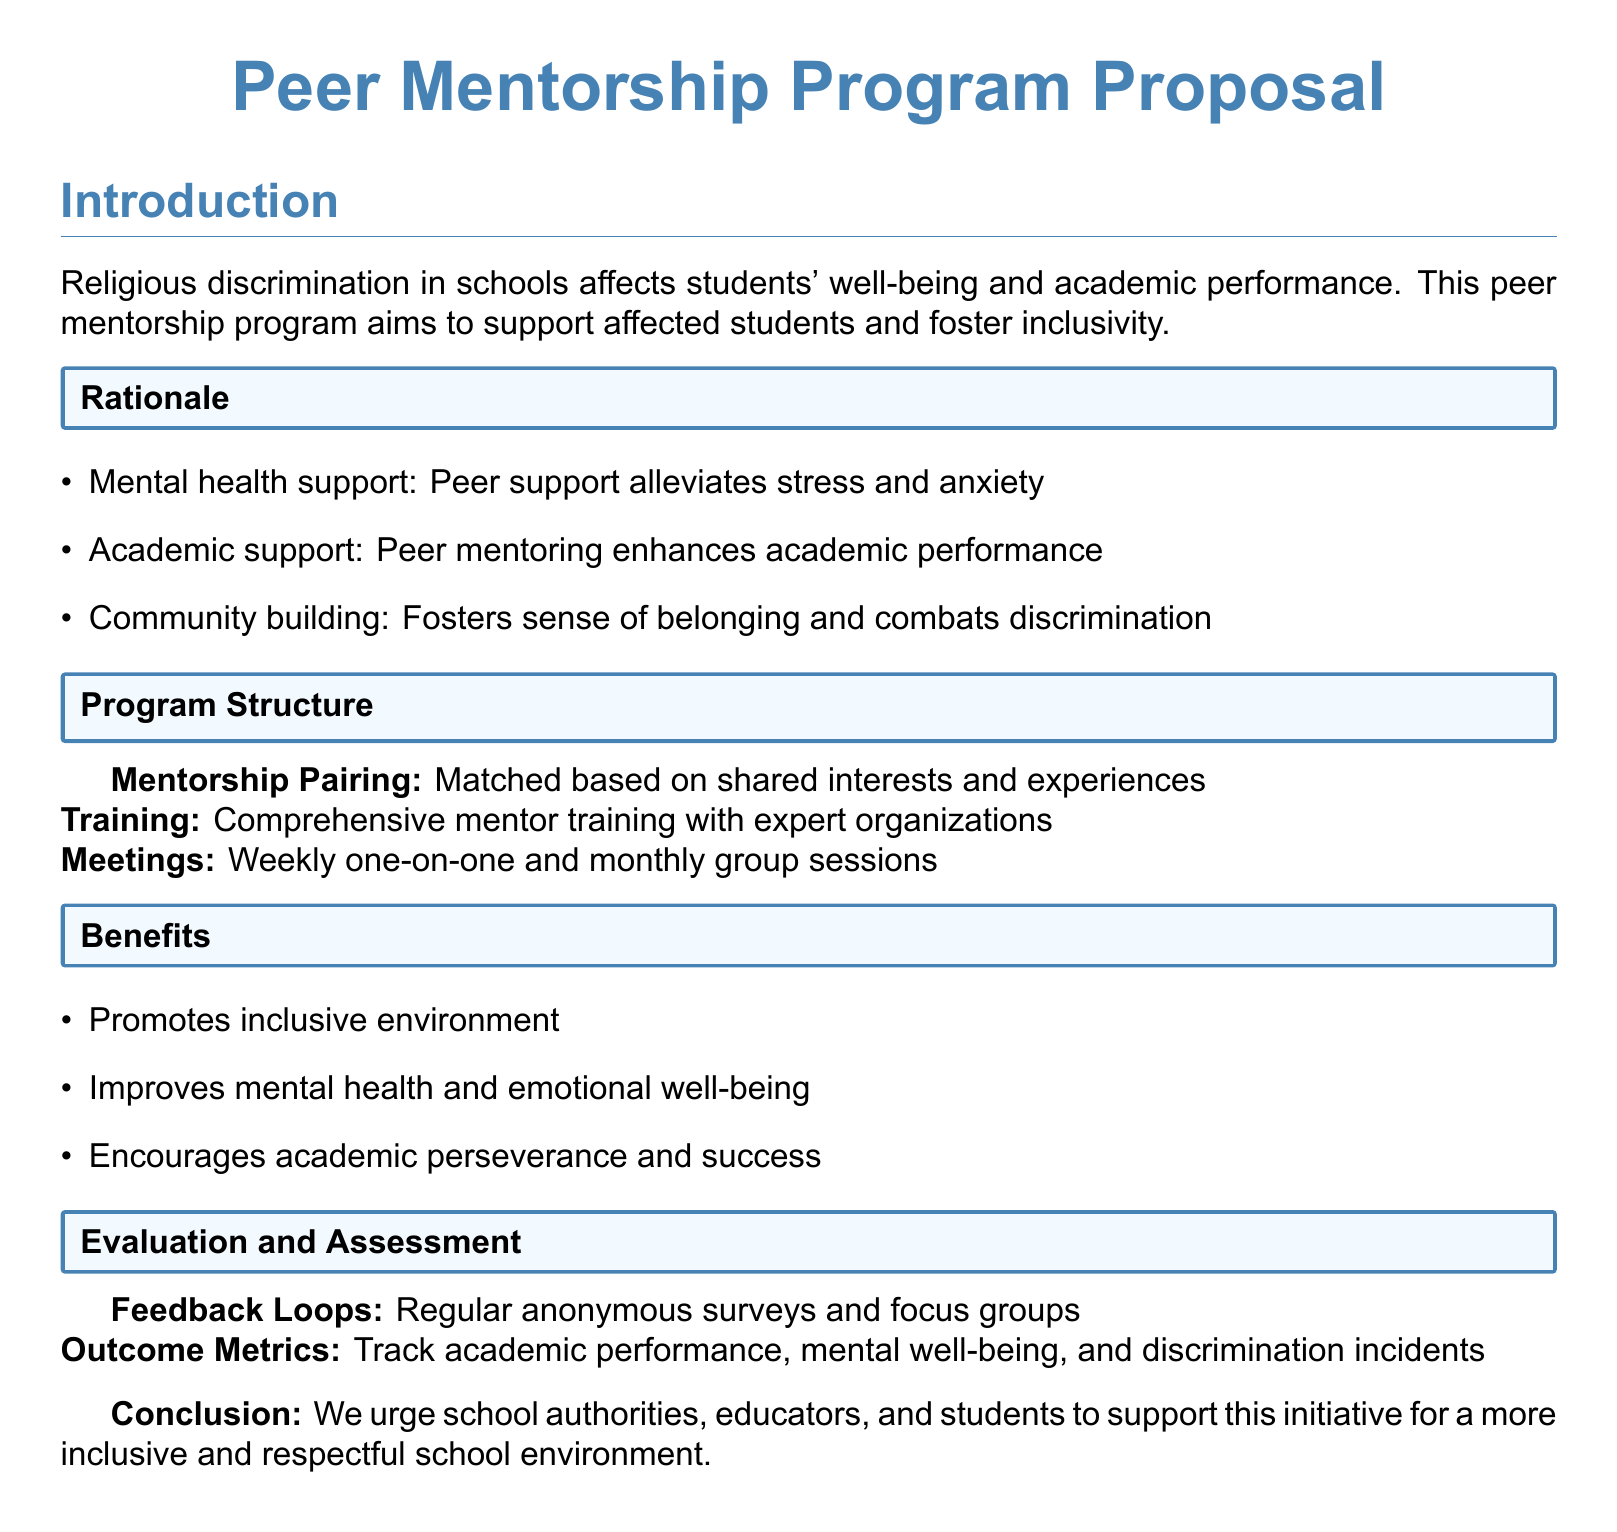what is the main purpose of the Peer Mentorship Program? The main purpose is to support students experiencing religious discrimination and foster inclusivity.
Answer: support students experiencing religious discrimination and foster inclusivity how often will one-on-one mentorship meetings occur? The document states that one-on-one meetings will be held weekly.
Answer: weekly what type of training will mentors receive? Mentors will receive comprehensive training with expert organizations.
Answer: comprehensive training with expert organizations name one benefit of the proposed mentorship program. The document lists several benefits, one being the promotion of an inclusive environment.
Answer: promotes inclusive environment how will the program evaluate its success? The program will evaluate success through regular anonymous surveys and focus groups.
Answer: regular anonymous surveys and focus groups what is a key factor for mentorship pairing? Mentorship pairing will be based on shared interests and experiences.
Answer: shared interests and experiences how many group sessions will be held each month? The proposal specifies one group session per month.
Answer: monthly what does the conclusion urge from the school authorities? The conclusion urges support for a more inclusive and respectful school environment.
Answer: support for a more inclusive and respectful school environment 